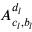Convert formula to latex. <formula><loc_0><loc_0><loc_500><loc_500>A _ { c _ { l } , b _ { l } } ^ { d _ { l } }</formula> 